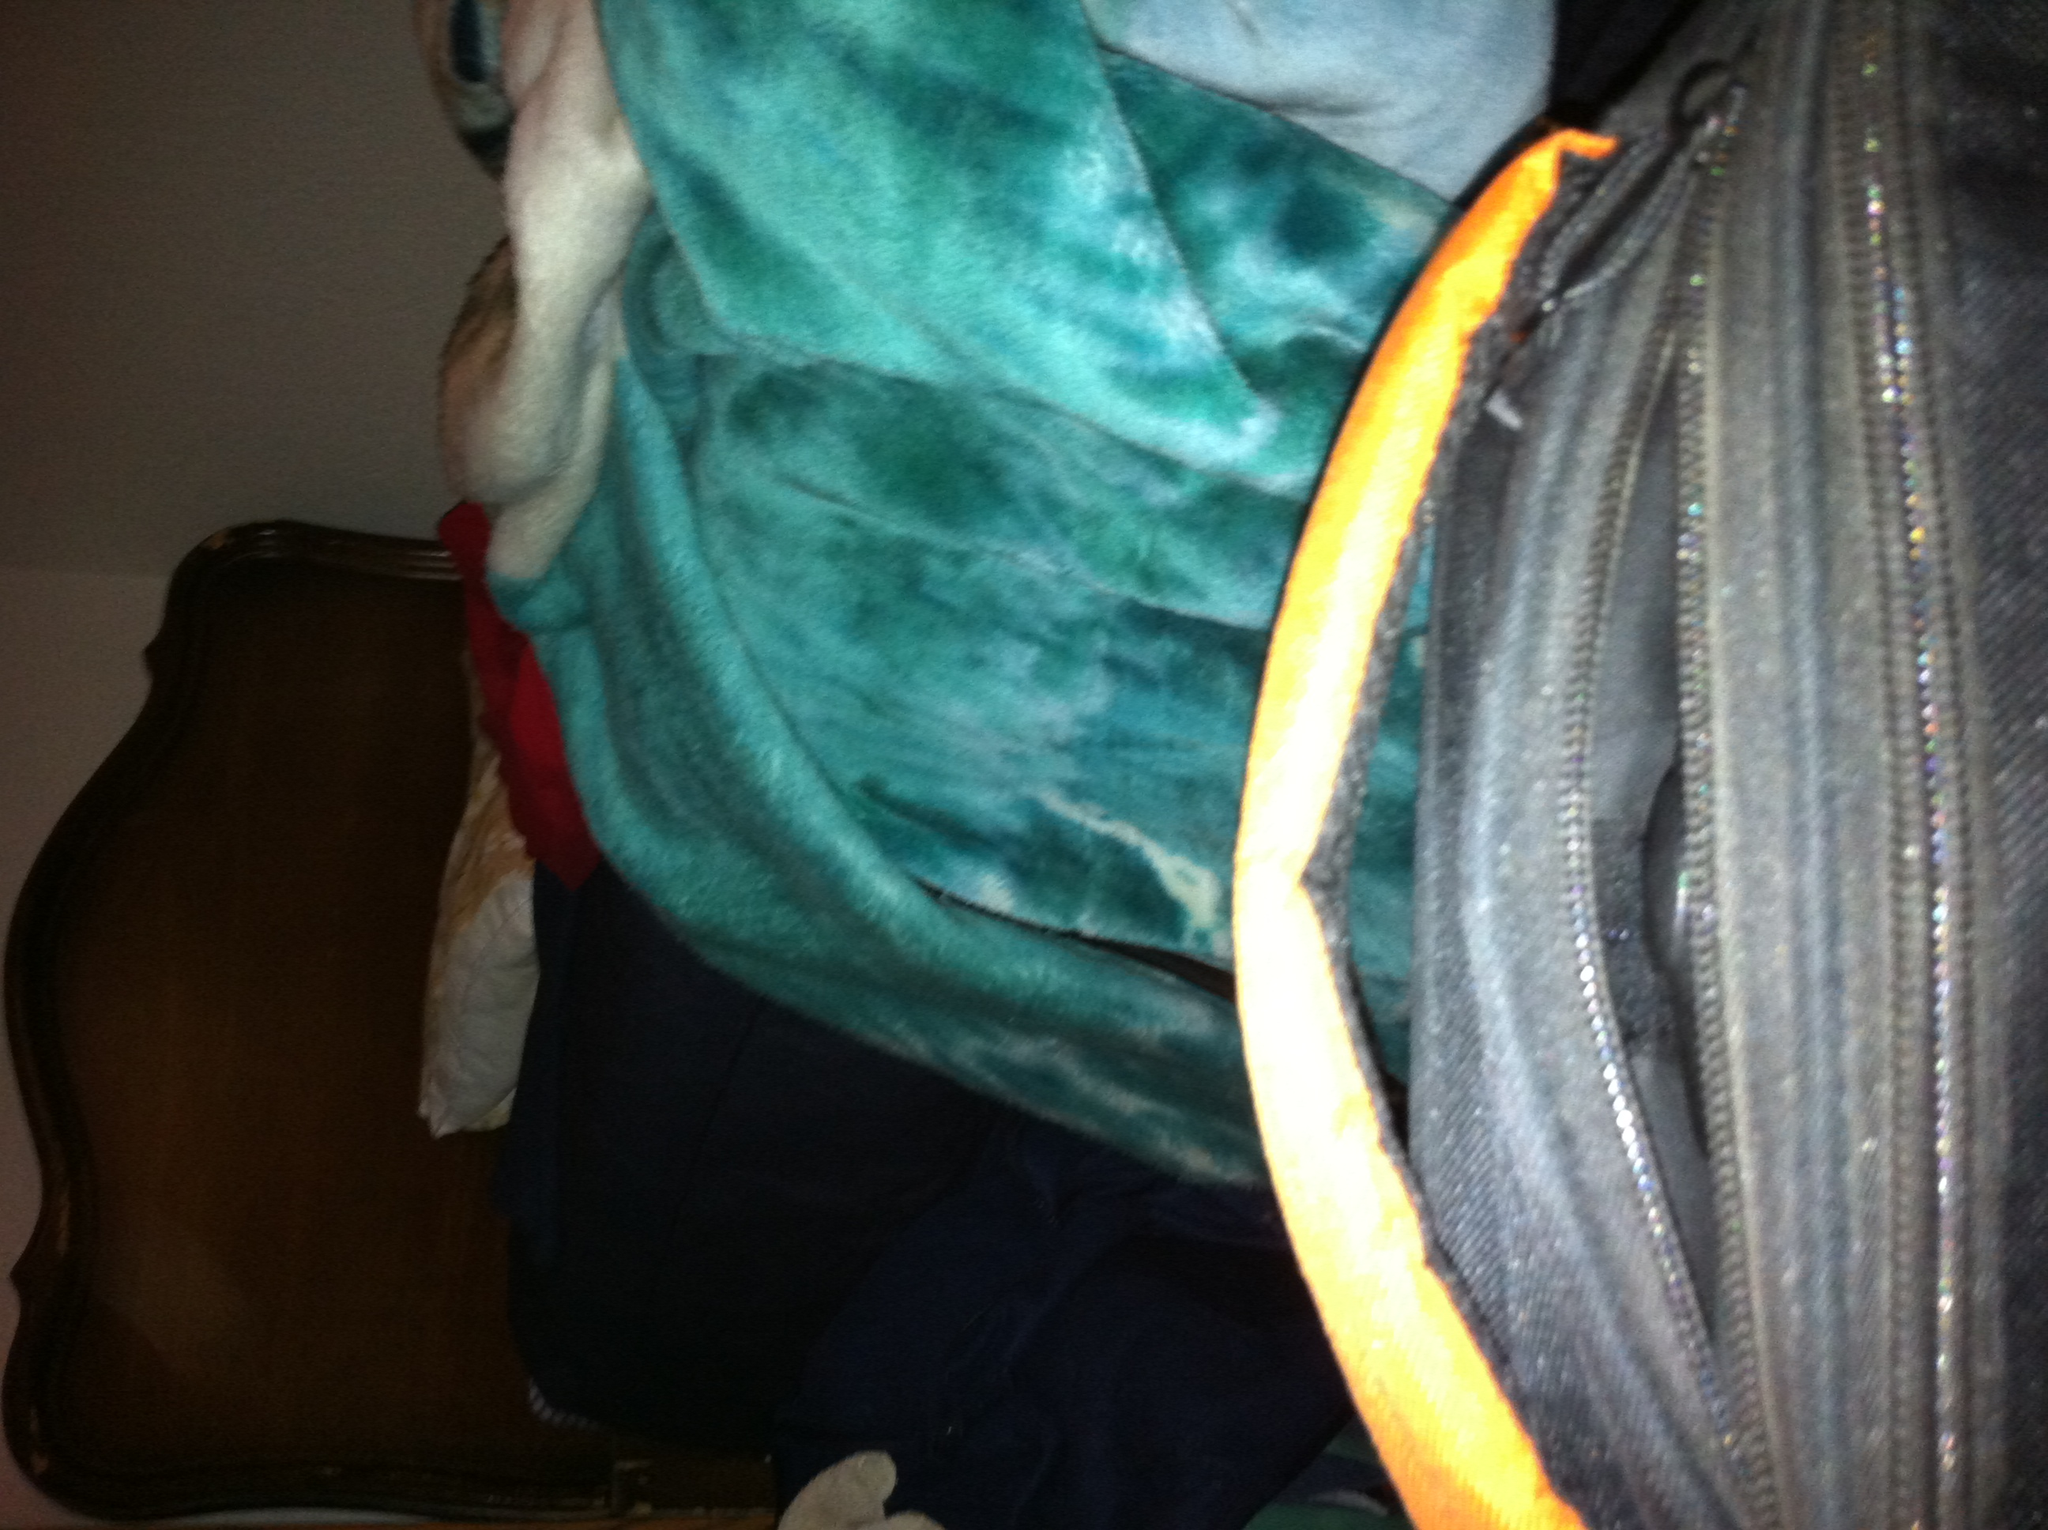What color is this bag? The bag in the image is primarily black, featuring a subtle textured pattern that may not be distinctly visible unless closely examined. 